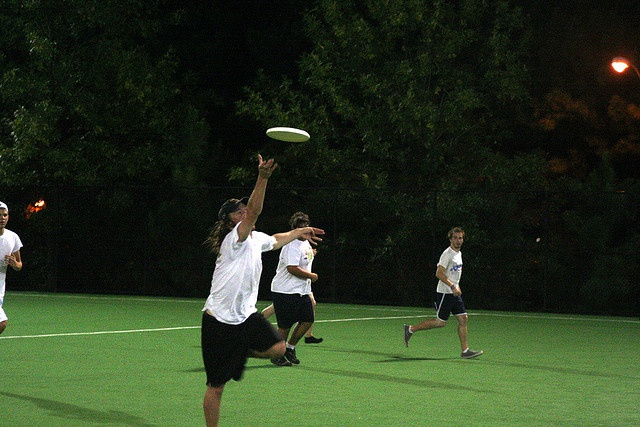Describe the objects in this image and their specific colors. I can see people in black, lightgray, olive, and darkgray tones, people in black, lavender, darkgray, and maroon tones, people in black, darkgreen, gray, and darkgray tones, people in black, white, gray, and darkgray tones, and frisbee in black, darkgreen, and ivory tones in this image. 